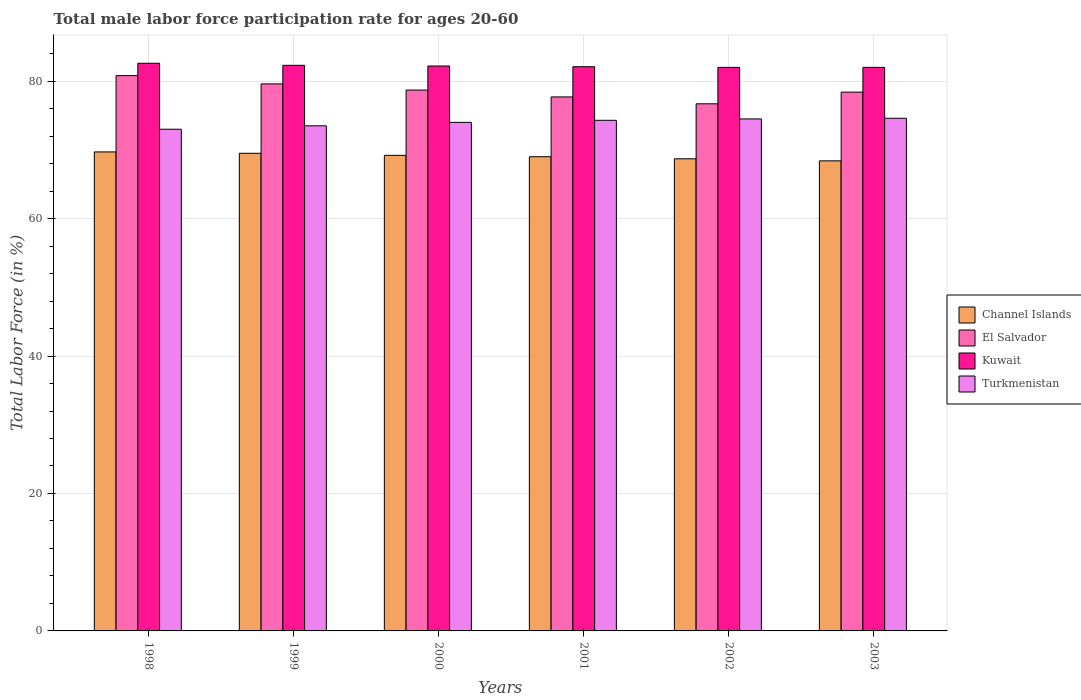Are the number of bars on each tick of the X-axis equal?
Provide a succinct answer. Yes. How many bars are there on the 2nd tick from the left?
Ensure brevity in your answer.  4. How many bars are there on the 4th tick from the right?
Your answer should be very brief. 4. What is the label of the 4th group of bars from the left?
Ensure brevity in your answer.  2001. In how many cases, is the number of bars for a given year not equal to the number of legend labels?
Your answer should be compact. 0. What is the male labor force participation rate in Kuwait in 2002?
Keep it short and to the point. 82. Across all years, what is the maximum male labor force participation rate in Turkmenistan?
Offer a very short reply. 74.6. Across all years, what is the minimum male labor force participation rate in El Salvador?
Provide a short and direct response. 76.7. In which year was the male labor force participation rate in Channel Islands maximum?
Give a very brief answer. 1998. In which year was the male labor force participation rate in El Salvador minimum?
Provide a short and direct response. 2002. What is the total male labor force participation rate in Kuwait in the graph?
Offer a very short reply. 493.2. What is the difference between the male labor force participation rate in Channel Islands in 2000 and that in 2003?
Give a very brief answer. 0.8. What is the difference between the male labor force participation rate in Channel Islands in 2000 and the male labor force participation rate in Turkmenistan in 1998?
Your response must be concise. -3.8. What is the average male labor force participation rate in El Salvador per year?
Keep it short and to the point. 78.65. In the year 2001, what is the difference between the male labor force participation rate in Channel Islands and male labor force participation rate in El Salvador?
Keep it short and to the point. -8.7. In how many years, is the male labor force participation rate in Kuwait greater than 60 %?
Provide a short and direct response. 6. What is the ratio of the male labor force participation rate in Turkmenistan in 1999 to that in 2000?
Ensure brevity in your answer.  0.99. Is the male labor force participation rate in Channel Islands in 2000 less than that in 2001?
Provide a succinct answer. No. What is the difference between the highest and the second highest male labor force participation rate in Kuwait?
Provide a short and direct response. 0.3. What is the difference between the highest and the lowest male labor force participation rate in Turkmenistan?
Your answer should be very brief. 1.6. What does the 3rd bar from the left in 2003 represents?
Ensure brevity in your answer.  Kuwait. What does the 4th bar from the right in 2001 represents?
Make the answer very short. Channel Islands. Is it the case that in every year, the sum of the male labor force participation rate in Channel Islands and male labor force participation rate in El Salvador is greater than the male labor force participation rate in Turkmenistan?
Provide a succinct answer. Yes. Are all the bars in the graph horizontal?
Your answer should be compact. No. Does the graph contain any zero values?
Provide a short and direct response. No. Does the graph contain grids?
Give a very brief answer. Yes. Where does the legend appear in the graph?
Provide a succinct answer. Center right. How many legend labels are there?
Your answer should be compact. 4. What is the title of the graph?
Offer a very short reply. Total male labor force participation rate for ages 20-60. What is the label or title of the Y-axis?
Your answer should be very brief. Total Labor Force (in %). What is the Total Labor Force (in %) of Channel Islands in 1998?
Offer a very short reply. 69.7. What is the Total Labor Force (in %) in El Salvador in 1998?
Offer a very short reply. 80.8. What is the Total Labor Force (in %) of Kuwait in 1998?
Provide a short and direct response. 82.6. What is the Total Labor Force (in %) of Turkmenistan in 1998?
Keep it short and to the point. 73. What is the Total Labor Force (in %) of Channel Islands in 1999?
Ensure brevity in your answer.  69.5. What is the Total Labor Force (in %) of El Salvador in 1999?
Your answer should be compact. 79.6. What is the Total Labor Force (in %) in Kuwait in 1999?
Ensure brevity in your answer.  82.3. What is the Total Labor Force (in %) in Turkmenistan in 1999?
Your response must be concise. 73.5. What is the Total Labor Force (in %) of Channel Islands in 2000?
Your answer should be very brief. 69.2. What is the Total Labor Force (in %) of El Salvador in 2000?
Keep it short and to the point. 78.7. What is the Total Labor Force (in %) of Kuwait in 2000?
Make the answer very short. 82.2. What is the Total Labor Force (in %) of El Salvador in 2001?
Your answer should be very brief. 77.7. What is the Total Labor Force (in %) of Kuwait in 2001?
Your answer should be compact. 82.1. What is the Total Labor Force (in %) of Turkmenistan in 2001?
Provide a succinct answer. 74.3. What is the Total Labor Force (in %) in Channel Islands in 2002?
Offer a very short reply. 68.7. What is the Total Labor Force (in %) in El Salvador in 2002?
Offer a very short reply. 76.7. What is the Total Labor Force (in %) of Kuwait in 2002?
Make the answer very short. 82. What is the Total Labor Force (in %) of Turkmenistan in 2002?
Your response must be concise. 74.5. What is the Total Labor Force (in %) of Channel Islands in 2003?
Offer a terse response. 68.4. What is the Total Labor Force (in %) of El Salvador in 2003?
Keep it short and to the point. 78.4. What is the Total Labor Force (in %) of Turkmenistan in 2003?
Keep it short and to the point. 74.6. Across all years, what is the maximum Total Labor Force (in %) in Channel Islands?
Your response must be concise. 69.7. Across all years, what is the maximum Total Labor Force (in %) in El Salvador?
Keep it short and to the point. 80.8. Across all years, what is the maximum Total Labor Force (in %) in Kuwait?
Your response must be concise. 82.6. Across all years, what is the maximum Total Labor Force (in %) of Turkmenistan?
Give a very brief answer. 74.6. Across all years, what is the minimum Total Labor Force (in %) in Channel Islands?
Give a very brief answer. 68.4. Across all years, what is the minimum Total Labor Force (in %) of El Salvador?
Ensure brevity in your answer.  76.7. What is the total Total Labor Force (in %) of Channel Islands in the graph?
Provide a succinct answer. 414.5. What is the total Total Labor Force (in %) of El Salvador in the graph?
Your answer should be very brief. 471.9. What is the total Total Labor Force (in %) in Kuwait in the graph?
Your answer should be very brief. 493.2. What is the total Total Labor Force (in %) of Turkmenistan in the graph?
Your answer should be very brief. 443.9. What is the difference between the Total Labor Force (in %) in Channel Islands in 1998 and that in 1999?
Keep it short and to the point. 0.2. What is the difference between the Total Labor Force (in %) of El Salvador in 1998 and that in 1999?
Give a very brief answer. 1.2. What is the difference between the Total Labor Force (in %) in Turkmenistan in 1998 and that in 1999?
Offer a terse response. -0.5. What is the difference between the Total Labor Force (in %) of El Salvador in 1998 and that in 2000?
Give a very brief answer. 2.1. What is the difference between the Total Labor Force (in %) of Kuwait in 1998 and that in 2000?
Ensure brevity in your answer.  0.4. What is the difference between the Total Labor Force (in %) of Channel Islands in 1998 and that in 2001?
Provide a short and direct response. 0.7. What is the difference between the Total Labor Force (in %) in Kuwait in 1998 and that in 2001?
Provide a short and direct response. 0.5. What is the difference between the Total Labor Force (in %) in Turkmenistan in 1998 and that in 2001?
Offer a very short reply. -1.3. What is the difference between the Total Labor Force (in %) in Channel Islands in 1998 and that in 2002?
Offer a terse response. 1. What is the difference between the Total Labor Force (in %) in Turkmenistan in 1998 and that in 2002?
Your response must be concise. -1.5. What is the difference between the Total Labor Force (in %) in Turkmenistan in 1998 and that in 2003?
Offer a terse response. -1.6. What is the difference between the Total Labor Force (in %) in El Salvador in 1999 and that in 2000?
Offer a very short reply. 0.9. What is the difference between the Total Labor Force (in %) of Kuwait in 1999 and that in 2000?
Your response must be concise. 0.1. What is the difference between the Total Labor Force (in %) of Channel Islands in 1999 and that in 2001?
Your response must be concise. 0.5. What is the difference between the Total Labor Force (in %) of Kuwait in 1999 and that in 2001?
Your response must be concise. 0.2. What is the difference between the Total Labor Force (in %) in Turkmenistan in 1999 and that in 2001?
Offer a very short reply. -0.8. What is the difference between the Total Labor Force (in %) of Channel Islands in 1999 and that in 2002?
Offer a terse response. 0.8. What is the difference between the Total Labor Force (in %) of El Salvador in 1999 and that in 2002?
Keep it short and to the point. 2.9. What is the difference between the Total Labor Force (in %) in Kuwait in 1999 and that in 2003?
Make the answer very short. 0.3. What is the difference between the Total Labor Force (in %) in Turkmenistan in 1999 and that in 2003?
Your response must be concise. -1.1. What is the difference between the Total Labor Force (in %) in Kuwait in 2000 and that in 2001?
Give a very brief answer. 0.1. What is the difference between the Total Labor Force (in %) in El Salvador in 2000 and that in 2002?
Ensure brevity in your answer.  2. What is the difference between the Total Labor Force (in %) in Kuwait in 2000 and that in 2002?
Your answer should be compact. 0.2. What is the difference between the Total Labor Force (in %) of Channel Islands in 2000 and that in 2003?
Offer a very short reply. 0.8. What is the difference between the Total Labor Force (in %) in El Salvador in 2000 and that in 2003?
Provide a succinct answer. 0.3. What is the difference between the Total Labor Force (in %) in Kuwait in 2000 and that in 2003?
Your answer should be very brief. 0.2. What is the difference between the Total Labor Force (in %) in Turkmenistan in 2000 and that in 2003?
Keep it short and to the point. -0.6. What is the difference between the Total Labor Force (in %) in Channel Islands in 2001 and that in 2002?
Give a very brief answer. 0.3. What is the difference between the Total Labor Force (in %) in Kuwait in 2001 and that in 2002?
Give a very brief answer. 0.1. What is the difference between the Total Labor Force (in %) of Channel Islands in 2001 and that in 2003?
Ensure brevity in your answer.  0.6. What is the difference between the Total Labor Force (in %) in El Salvador in 2001 and that in 2003?
Give a very brief answer. -0.7. What is the difference between the Total Labor Force (in %) in Turkmenistan in 2001 and that in 2003?
Keep it short and to the point. -0.3. What is the difference between the Total Labor Force (in %) of Channel Islands in 2002 and that in 2003?
Give a very brief answer. 0.3. What is the difference between the Total Labor Force (in %) of El Salvador in 2002 and that in 2003?
Offer a terse response. -1.7. What is the difference between the Total Labor Force (in %) of Kuwait in 2002 and that in 2003?
Provide a short and direct response. 0. What is the difference between the Total Labor Force (in %) of Turkmenistan in 2002 and that in 2003?
Your answer should be very brief. -0.1. What is the difference between the Total Labor Force (in %) in Channel Islands in 1998 and the Total Labor Force (in %) in El Salvador in 1999?
Your answer should be compact. -9.9. What is the difference between the Total Labor Force (in %) in Channel Islands in 1998 and the Total Labor Force (in %) in Kuwait in 1999?
Offer a terse response. -12.6. What is the difference between the Total Labor Force (in %) in Channel Islands in 1998 and the Total Labor Force (in %) in Turkmenistan in 1999?
Your answer should be compact. -3.8. What is the difference between the Total Labor Force (in %) in El Salvador in 1998 and the Total Labor Force (in %) in Kuwait in 1999?
Keep it short and to the point. -1.5. What is the difference between the Total Labor Force (in %) of Kuwait in 1998 and the Total Labor Force (in %) of Turkmenistan in 1999?
Keep it short and to the point. 9.1. What is the difference between the Total Labor Force (in %) of Channel Islands in 1998 and the Total Labor Force (in %) of El Salvador in 2000?
Provide a short and direct response. -9. What is the difference between the Total Labor Force (in %) of Channel Islands in 1998 and the Total Labor Force (in %) of Kuwait in 2000?
Provide a short and direct response. -12.5. What is the difference between the Total Labor Force (in %) in El Salvador in 1998 and the Total Labor Force (in %) in Turkmenistan in 2000?
Your answer should be compact. 6.8. What is the difference between the Total Labor Force (in %) of Kuwait in 1998 and the Total Labor Force (in %) of Turkmenistan in 2000?
Provide a succinct answer. 8.6. What is the difference between the Total Labor Force (in %) of Channel Islands in 1998 and the Total Labor Force (in %) of El Salvador in 2001?
Offer a very short reply. -8. What is the difference between the Total Labor Force (in %) of Channel Islands in 1998 and the Total Labor Force (in %) of Kuwait in 2001?
Your answer should be compact. -12.4. What is the difference between the Total Labor Force (in %) of El Salvador in 1998 and the Total Labor Force (in %) of Kuwait in 2001?
Keep it short and to the point. -1.3. What is the difference between the Total Labor Force (in %) in Channel Islands in 1998 and the Total Labor Force (in %) in El Salvador in 2002?
Keep it short and to the point. -7. What is the difference between the Total Labor Force (in %) in Channel Islands in 1998 and the Total Labor Force (in %) in Turkmenistan in 2002?
Provide a succinct answer. -4.8. What is the difference between the Total Labor Force (in %) in El Salvador in 1998 and the Total Labor Force (in %) in Turkmenistan in 2002?
Offer a terse response. 6.3. What is the difference between the Total Labor Force (in %) in Channel Islands in 1998 and the Total Labor Force (in %) in El Salvador in 2003?
Offer a terse response. -8.7. What is the difference between the Total Labor Force (in %) in Channel Islands in 1998 and the Total Labor Force (in %) in Turkmenistan in 2003?
Your answer should be compact. -4.9. What is the difference between the Total Labor Force (in %) in El Salvador in 1998 and the Total Labor Force (in %) in Turkmenistan in 2003?
Keep it short and to the point. 6.2. What is the difference between the Total Labor Force (in %) of Channel Islands in 1999 and the Total Labor Force (in %) of Kuwait in 2000?
Your answer should be very brief. -12.7. What is the difference between the Total Labor Force (in %) of Channel Islands in 1999 and the Total Labor Force (in %) of El Salvador in 2001?
Provide a succinct answer. -8.2. What is the difference between the Total Labor Force (in %) in Channel Islands in 1999 and the Total Labor Force (in %) in Kuwait in 2001?
Provide a succinct answer. -12.6. What is the difference between the Total Labor Force (in %) in El Salvador in 1999 and the Total Labor Force (in %) in Turkmenistan in 2001?
Provide a succinct answer. 5.3. What is the difference between the Total Labor Force (in %) of Channel Islands in 1999 and the Total Labor Force (in %) of Kuwait in 2002?
Make the answer very short. -12.5. What is the difference between the Total Labor Force (in %) in El Salvador in 1999 and the Total Labor Force (in %) in Turkmenistan in 2002?
Give a very brief answer. 5.1. What is the difference between the Total Labor Force (in %) in Channel Islands in 1999 and the Total Labor Force (in %) in El Salvador in 2003?
Your response must be concise. -8.9. What is the difference between the Total Labor Force (in %) of Channel Islands in 1999 and the Total Labor Force (in %) of Kuwait in 2003?
Your response must be concise. -12.5. What is the difference between the Total Labor Force (in %) in El Salvador in 1999 and the Total Labor Force (in %) in Kuwait in 2003?
Offer a very short reply. -2.4. What is the difference between the Total Labor Force (in %) in El Salvador in 1999 and the Total Labor Force (in %) in Turkmenistan in 2003?
Make the answer very short. 5. What is the difference between the Total Labor Force (in %) of Channel Islands in 2000 and the Total Labor Force (in %) of Kuwait in 2001?
Offer a very short reply. -12.9. What is the difference between the Total Labor Force (in %) in El Salvador in 2000 and the Total Labor Force (in %) in Turkmenistan in 2001?
Your answer should be very brief. 4.4. What is the difference between the Total Labor Force (in %) of Channel Islands in 2000 and the Total Labor Force (in %) of Turkmenistan in 2002?
Provide a short and direct response. -5.3. What is the difference between the Total Labor Force (in %) of El Salvador in 2000 and the Total Labor Force (in %) of Kuwait in 2002?
Your answer should be very brief. -3.3. What is the difference between the Total Labor Force (in %) in Channel Islands in 2000 and the Total Labor Force (in %) in El Salvador in 2003?
Make the answer very short. -9.2. What is the difference between the Total Labor Force (in %) in Channel Islands in 2000 and the Total Labor Force (in %) in Kuwait in 2003?
Your answer should be very brief. -12.8. What is the difference between the Total Labor Force (in %) in Channel Islands in 2000 and the Total Labor Force (in %) in Turkmenistan in 2003?
Make the answer very short. -5.4. What is the difference between the Total Labor Force (in %) in El Salvador in 2000 and the Total Labor Force (in %) in Kuwait in 2003?
Provide a short and direct response. -3.3. What is the difference between the Total Labor Force (in %) of Channel Islands in 2001 and the Total Labor Force (in %) of Kuwait in 2002?
Keep it short and to the point. -13. What is the difference between the Total Labor Force (in %) in El Salvador in 2001 and the Total Labor Force (in %) in Kuwait in 2002?
Your answer should be compact. -4.3. What is the difference between the Total Labor Force (in %) of El Salvador in 2001 and the Total Labor Force (in %) of Turkmenistan in 2002?
Your answer should be compact. 3.2. What is the difference between the Total Labor Force (in %) in Channel Islands in 2001 and the Total Labor Force (in %) in El Salvador in 2003?
Your answer should be compact. -9.4. What is the difference between the Total Labor Force (in %) of Channel Islands in 2001 and the Total Labor Force (in %) of Kuwait in 2003?
Make the answer very short. -13. What is the difference between the Total Labor Force (in %) of Channel Islands in 2001 and the Total Labor Force (in %) of Turkmenistan in 2003?
Your response must be concise. -5.6. What is the difference between the Total Labor Force (in %) in Kuwait in 2001 and the Total Labor Force (in %) in Turkmenistan in 2003?
Your answer should be very brief. 7.5. What is the difference between the Total Labor Force (in %) in Channel Islands in 2002 and the Total Labor Force (in %) in Turkmenistan in 2003?
Keep it short and to the point. -5.9. What is the difference between the Total Labor Force (in %) in El Salvador in 2002 and the Total Labor Force (in %) in Kuwait in 2003?
Make the answer very short. -5.3. What is the difference between the Total Labor Force (in %) in El Salvador in 2002 and the Total Labor Force (in %) in Turkmenistan in 2003?
Offer a very short reply. 2.1. What is the average Total Labor Force (in %) of Channel Islands per year?
Your answer should be compact. 69.08. What is the average Total Labor Force (in %) in El Salvador per year?
Provide a succinct answer. 78.65. What is the average Total Labor Force (in %) in Kuwait per year?
Offer a very short reply. 82.2. What is the average Total Labor Force (in %) of Turkmenistan per year?
Provide a succinct answer. 73.98. In the year 1998, what is the difference between the Total Labor Force (in %) in Channel Islands and Total Labor Force (in %) in Kuwait?
Make the answer very short. -12.9. In the year 1998, what is the difference between the Total Labor Force (in %) in El Salvador and Total Labor Force (in %) in Kuwait?
Give a very brief answer. -1.8. In the year 1998, what is the difference between the Total Labor Force (in %) in Kuwait and Total Labor Force (in %) in Turkmenistan?
Your answer should be very brief. 9.6. In the year 1999, what is the difference between the Total Labor Force (in %) in Channel Islands and Total Labor Force (in %) in El Salvador?
Give a very brief answer. -10.1. In the year 1999, what is the difference between the Total Labor Force (in %) in Channel Islands and Total Labor Force (in %) in Kuwait?
Provide a short and direct response. -12.8. In the year 1999, what is the difference between the Total Labor Force (in %) of Kuwait and Total Labor Force (in %) of Turkmenistan?
Provide a short and direct response. 8.8. In the year 2000, what is the difference between the Total Labor Force (in %) of Channel Islands and Total Labor Force (in %) of Turkmenistan?
Provide a succinct answer. -4.8. In the year 2000, what is the difference between the Total Labor Force (in %) of El Salvador and Total Labor Force (in %) of Turkmenistan?
Provide a short and direct response. 4.7. In the year 2000, what is the difference between the Total Labor Force (in %) in Kuwait and Total Labor Force (in %) in Turkmenistan?
Keep it short and to the point. 8.2. In the year 2001, what is the difference between the Total Labor Force (in %) of Channel Islands and Total Labor Force (in %) of El Salvador?
Provide a succinct answer. -8.7. In the year 2001, what is the difference between the Total Labor Force (in %) in Channel Islands and Total Labor Force (in %) in Kuwait?
Your response must be concise. -13.1. In the year 2001, what is the difference between the Total Labor Force (in %) in Channel Islands and Total Labor Force (in %) in Turkmenistan?
Offer a very short reply. -5.3. In the year 2001, what is the difference between the Total Labor Force (in %) in El Salvador and Total Labor Force (in %) in Kuwait?
Provide a short and direct response. -4.4. In the year 2001, what is the difference between the Total Labor Force (in %) in El Salvador and Total Labor Force (in %) in Turkmenistan?
Make the answer very short. 3.4. In the year 2001, what is the difference between the Total Labor Force (in %) of Kuwait and Total Labor Force (in %) of Turkmenistan?
Your answer should be compact. 7.8. In the year 2002, what is the difference between the Total Labor Force (in %) in Channel Islands and Total Labor Force (in %) in Kuwait?
Ensure brevity in your answer.  -13.3. In the year 2002, what is the difference between the Total Labor Force (in %) of El Salvador and Total Labor Force (in %) of Kuwait?
Provide a succinct answer. -5.3. In the year 2002, what is the difference between the Total Labor Force (in %) in Kuwait and Total Labor Force (in %) in Turkmenistan?
Offer a very short reply. 7.5. In the year 2003, what is the difference between the Total Labor Force (in %) of Channel Islands and Total Labor Force (in %) of Turkmenistan?
Provide a succinct answer. -6.2. In the year 2003, what is the difference between the Total Labor Force (in %) in El Salvador and Total Labor Force (in %) in Kuwait?
Keep it short and to the point. -3.6. What is the ratio of the Total Labor Force (in %) in Channel Islands in 1998 to that in 1999?
Your answer should be compact. 1. What is the ratio of the Total Labor Force (in %) of El Salvador in 1998 to that in 1999?
Keep it short and to the point. 1.02. What is the ratio of the Total Labor Force (in %) of Turkmenistan in 1998 to that in 1999?
Make the answer very short. 0.99. What is the ratio of the Total Labor Force (in %) in El Salvador in 1998 to that in 2000?
Offer a terse response. 1.03. What is the ratio of the Total Labor Force (in %) in Turkmenistan in 1998 to that in 2000?
Keep it short and to the point. 0.99. What is the ratio of the Total Labor Force (in %) in Channel Islands in 1998 to that in 2001?
Make the answer very short. 1.01. What is the ratio of the Total Labor Force (in %) of El Salvador in 1998 to that in 2001?
Make the answer very short. 1.04. What is the ratio of the Total Labor Force (in %) of Kuwait in 1998 to that in 2001?
Give a very brief answer. 1.01. What is the ratio of the Total Labor Force (in %) of Turkmenistan in 1998 to that in 2001?
Offer a very short reply. 0.98. What is the ratio of the Total Labor Force (in %) of Channel Islands in 1998 to that in 2002?
Your answer should be compact. 1.01. What is the ratio of the Total Labor Force (in %) in El Salvador in 1998 to that in 2002?
Provide a succinct answer. 1.05. What is the ratio of the Total Labor Force (in %) of Kuwait in 1998 to that in 2002?
Provide a short and direct response. 1.01. What is the ratio of the Total Labor Force (in %) of Turkmenistan in 1998 to that in 2002?
Your answer should be very brief. 0.98. What is the ratio of the Total Labor Force (in %) of Channel Islands in 1998 to that in 2003?
Offer a terse response. 1.02. What is the ratio of the Total Labor Force (in %) of El Salvador in 1998 to that in 2003?
Your answer should be compact. 1.03. What is the ratio of the Total Labor Force (in %) of Kuwait in 1998 to that in 2003?
Provide a short and direct response. 1.01. What is the ratio of the Total Labor Force (in %) in Turkmenistan in 1998 to that in 2003?
Provide a succinct answer. 0.98. What is the ratio of the Total Labor Force (in %) in El Salvador in 1999 to that in 2000?
Provide a succinct answer. 1.01. What is the ratio of the Total Labor Force (in %) of Turkmenistan in 1999 to that in 2000?
Give a very brief answer. 0.99. What is the ratio of the Total Labor Force (in %) in El Salvador in 1999 to that in 2001?
Give a very brief answer. 1.02. What is the ratio of the Total Labor Force (in %) of Turkmenistan in 1999 to that in 2001?
Provide a succinct answer. 0.99. What is the ratio of the Total Labor Force (in %) of Channel Islands in 1999 to that in 2002?
Your answer should be compact. 1.01. What is the ratio of the Total Labor Force (in %) of El Salvador in 1999 to that in 2002?
Your answer should be very brief. 1.04. What is the ratio of the Total Labor Force (in %) in Turkmenistan in 1999 to that in 2002?
Make the answer very short. 0.99. What is the ratio of the Total Labor Force (in %) in Channel Islands in 1999 to that in 2003?
Your response must be concise. 1.02. What is the ratio of the Total Labor Force (in %) in El Salvador in 1999 to that in 2003?
Your answer should be compact. 1.02. What is the ratio of the Total Labor Force (in %) in Kuwait in 1999 to that in 2003?
Give a very brief answer. 1. What is the ratio of the Total Labor Force (in %) of El Salvador in 2000 to that in 2001?
Your answer should be compact. 1.01. What is the ratio of the Total Labor Force (in %) of Kuwait in 2000 to that in 2001?
Make the answer very short. 1. What is the ratio of the Total Labor Force (in %) of Turkmenistan in 2000 to that in 2001?
Provide a short and direct response. 1. What is the ratio of the Total Labor Force (in %) of Channel Islands in 2000 to that in 2002?
Your response must be concise. 1.01. What is the ratio of the Total Labor Force (in %) in El Salvador in 2000 to that in 2002?
Provide a succinct answer. 1.03. What is the ratio of the Total Labor Force (in %) of Turkmenistan in 2000 to that in 2002?
Your answer should be compact. 0.99. What is the ratio of the Total Labor Force (in %) in Channel Islands in 2000 to that in 2003?
Offer a very short reply. 1.01. What is the ratio of the Total Labor Force (in %) in El Salvador in 2000 to that in 2003?
Make the answer very short. 1. What is the ratio of the Total Labor Force (in %) of El Salvador in 2001 to that in 2002?
Make the answer very short. 1.01. What is the ratio of the Total Labor Force (in %) in Kuwait in 2001 to that in 2002?
Give a very brief answer. 1. What is the ratio of the Total Labor Force (in %) of Channel Islands in 2001 to that in 2003?
Make the answer very short. 1.01. What is the ratio of the Total Labor Force (in %) in Kuwait in 2001 to that in 2003?
Keep it short and to the point. 1. What is the ratio of the Total Labor Force (in %) in Turkmenistan in 2001 to that in 2003?
Provide a short and direct response. 1. What is the ratio of the Total Labor Force (in %) in Channel Islands in 2002 to that in 2003?
Your answer should be very brief. 1. What is the ratio of the Total Labor Force (in %) in El Salvador in 2002 to that in 2003?
Your answer should be very brief. 0.98. What is the ratio of the Total Labor Force (in %) in Kuwait in 2002 to that in 2003?
Your answer should be compact. 1. What is the ratio of the Total Labor Force (in %) of Turkmenistan in 2002 to that in 2003?
Offer a very short reply. 1. What is the difference between the highest and the second highest Total Labor Force (in %) of Channel Islands?
Offer a terse response. 0.2. What is the difference between the highest and the second highest Total Labor Force (in %) of El Salvador?
Your response must be concise. 1.2. What is the difference between the highest and the second highest Total Labor Force (in %) of Kuwait?
Your response must be concise. 0.3. What is the difference between the highest and the second highest Total Labor Force (in %) of Turkmenistan?
Keep it short and to the point. 0.1. What is the difference between the highest and the lowest Total Labor Force (in %) of Channel Islands?
Your response must be concise. 1.3. What is the difference between the highest and the lowest Total Labor Force (in %) in Kuwait?
Ensure brevity in your answer.  0.6. 